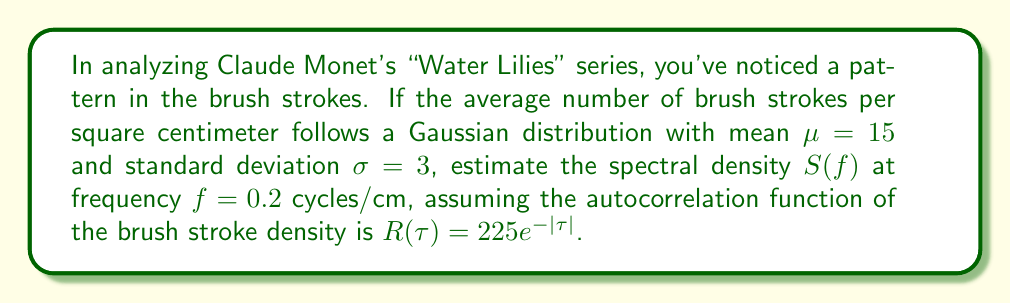Can you answer this question? To estimate the spectral density, we'll follow these steps:

1) The spectral density $S(f)$ is the Fourier transform of the autocorrelation function $R(\tau)$. For a given autocorrelation function $R(\tau) = ae^{-b|\tau|}$, the spectral density is:

   $$S(f) = \frac{2ab}{b^2 + (2\pi f)^2}$$

2) In our case, $R(\tau) = 225e^{-|\tau|}$, so $a = 225$ and $b = 1$.

3) Substituting these values and $f = 0.2$ into the formula:

   $$S(0.2) = \frac{2 \cdot 225 \cdot 1}{1^2 + (2\pi \cdot 0.2)^2}$$

4) Simplify:
   $$S(0.2) = \frac{450}{1 + (0.4\pi)^2} = \frac{450}{1 + 1.5791} = \frac{450}{2.5791}$$

5) Calculate the final value:
   $$S(0.2) \approx 174.48$$

This value represents the power spectral density of brush strokes at 0.2 cycles/cm, indicating the intensity of brush stroke patterns at this spatial frequency in Monet's "Water Lilies" series.
Answer: $174.48$ (brush strokes)$^2$/cm 